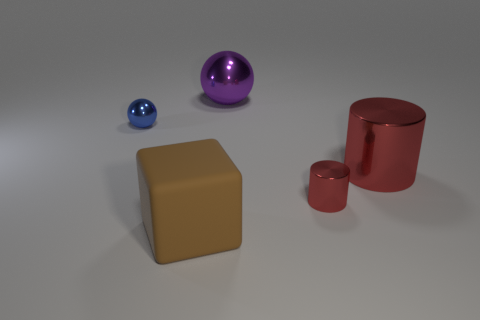Add 3 big purple shiny objects. How many objects exist? 8 Subtract 2 cylinders. How many cylinders are left? 0 Subtract all blue spheres. How many spheres are left? 1 Subtract all green spheres. Subtract all yellow blocks. How many spheres are left? 2 Subtract all purple cylinders. How many purple balls are left? 1 Subtract all tiny red rubber objects. Subtract all small metallic balls. How many objects are left? 4 Add 1 metallic objects. How many metallic objects are left? 5 Add 4 yellow metallic cylinders. How many yellow metallic cylinders exist? 4 Subtract 0 gray spheres. How many objects are left? 5 Subtract all balls. How many objects are left? 3 